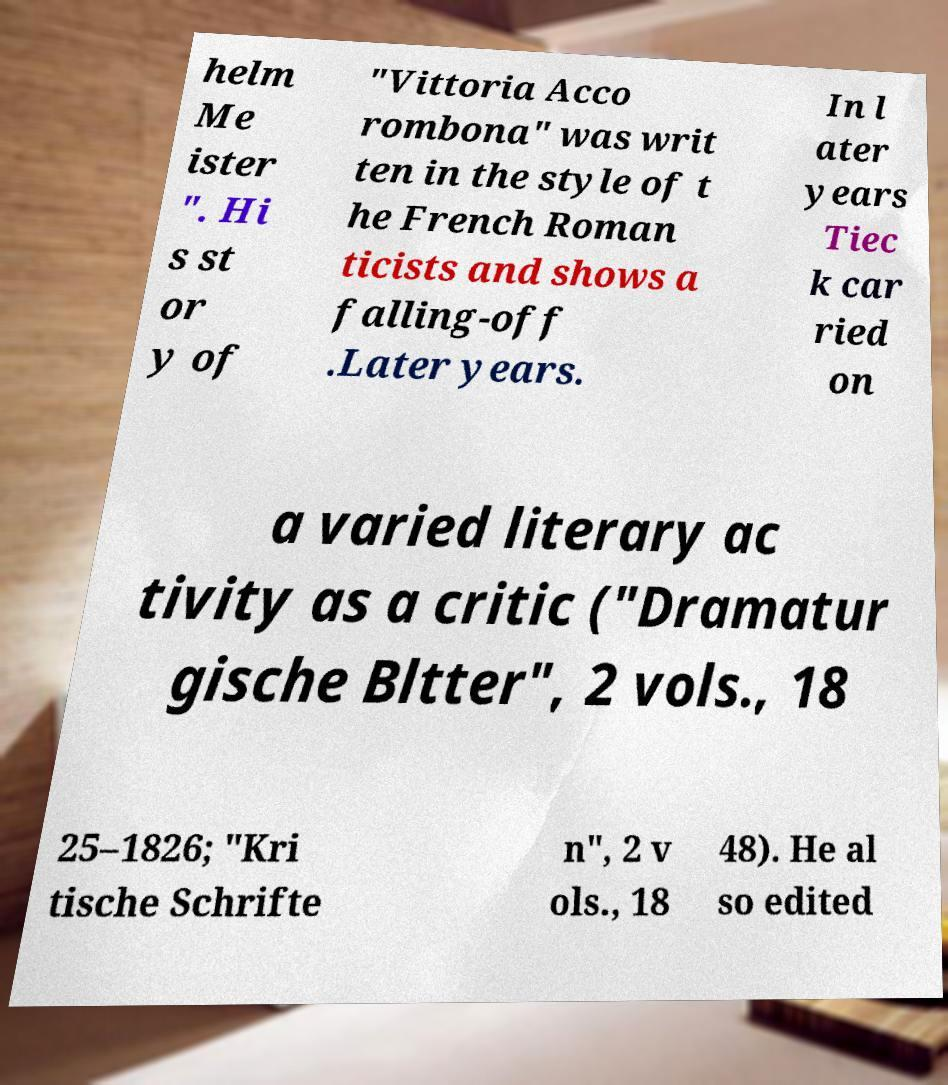Can you read and provide the text displayed in the image?This photo seems to have some interesting text. Can you extract and type it out for me? helm Me ister ". Hi s st or y of "Vittoria Acco rombona" was writ ten in the style of t he French Roman ticists and shows a falling-off .Later years. In l ater years Tiec k car ried on a varied literary ac tivity as a critic ("Dramatur gische Bltter", 2 vols., 18 25–1826; "Kri tische Schrifte n", 2 v ols., 18 48). He al so edited 